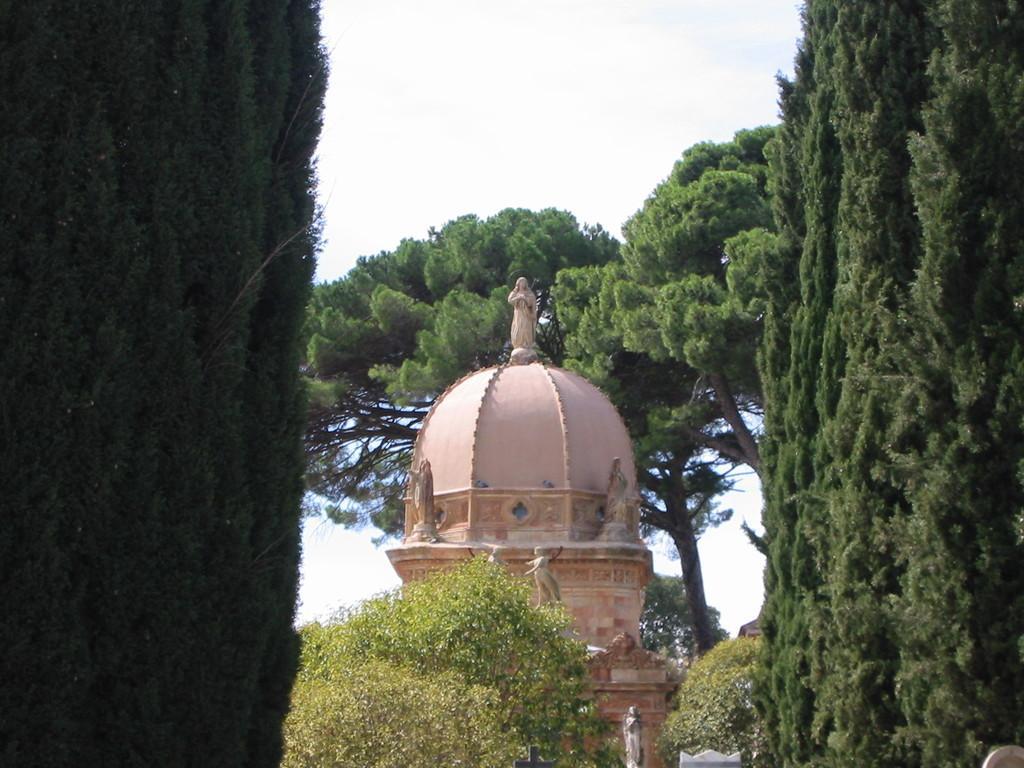Describe this image in one or two sentences. In this image we can see the trees on the left side and the right side as well. Here we can see the dome construction. This is a sky. 